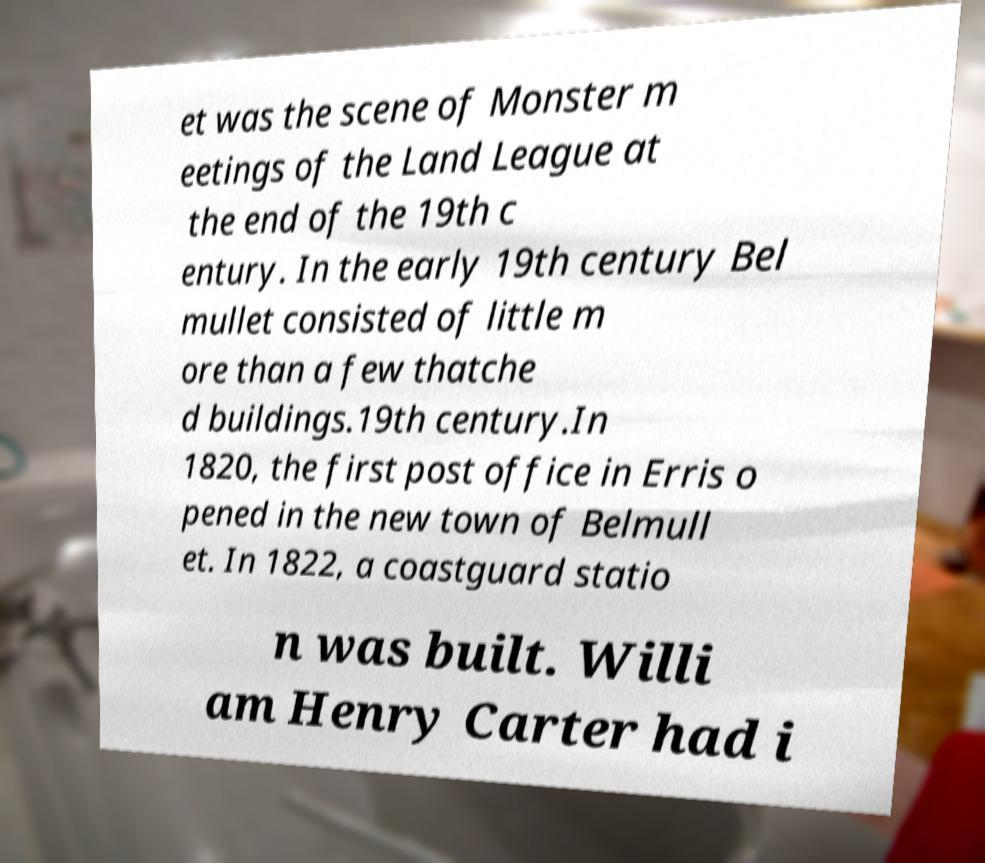What messages or text are displayed in this image? I need them in a readable, typed format. et was the scene of Monster m eetings of the Land League at the end of the 19th c entury. In the early 19th century Bel mullet consisted of little m ore than a few thatche d buildings.19th century.In 1820, the first post office in Erris o pened in the new town of Belmull et. In 1822, a coastguard statio n was built. Willi am Henry Carter had i 